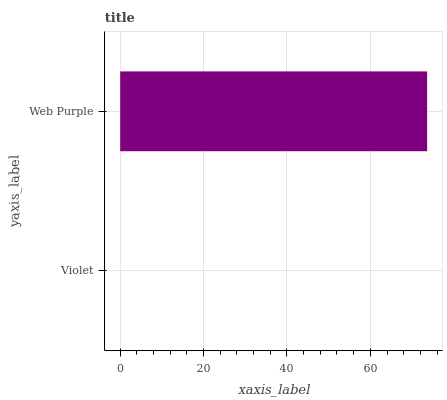Is Violet the minimum?
Answer yes or no. Yes. Is Web Purple the maximum?
Answer yes or no. Yes. Is Web Purple the minimum?
Answer yes or no. No. Is Web Purple greater than Violet?
Answer yes or no. Yes. Is Violet less than Web Purple?
Answer yes or no. Yes. Is Violet greater than Web Purple?
Answer yes or no. No. Is Web Purple less than Violet?
Answer yes or no. No. Is Web Purple the high median?
Answer yes or no. Yes. Is Violet the low median?
Answer yes or no. Yes. Is Violet the high median?
Answer yes or no. No. Is Web Purple the low median?
Answer yes or no. No. 